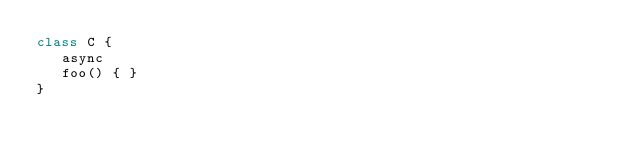Convert code to text. <code><loc_0><loc_0><loc_500><loc_500><_TypeScript_>class C {
   async
   foo() { }
}</code> 